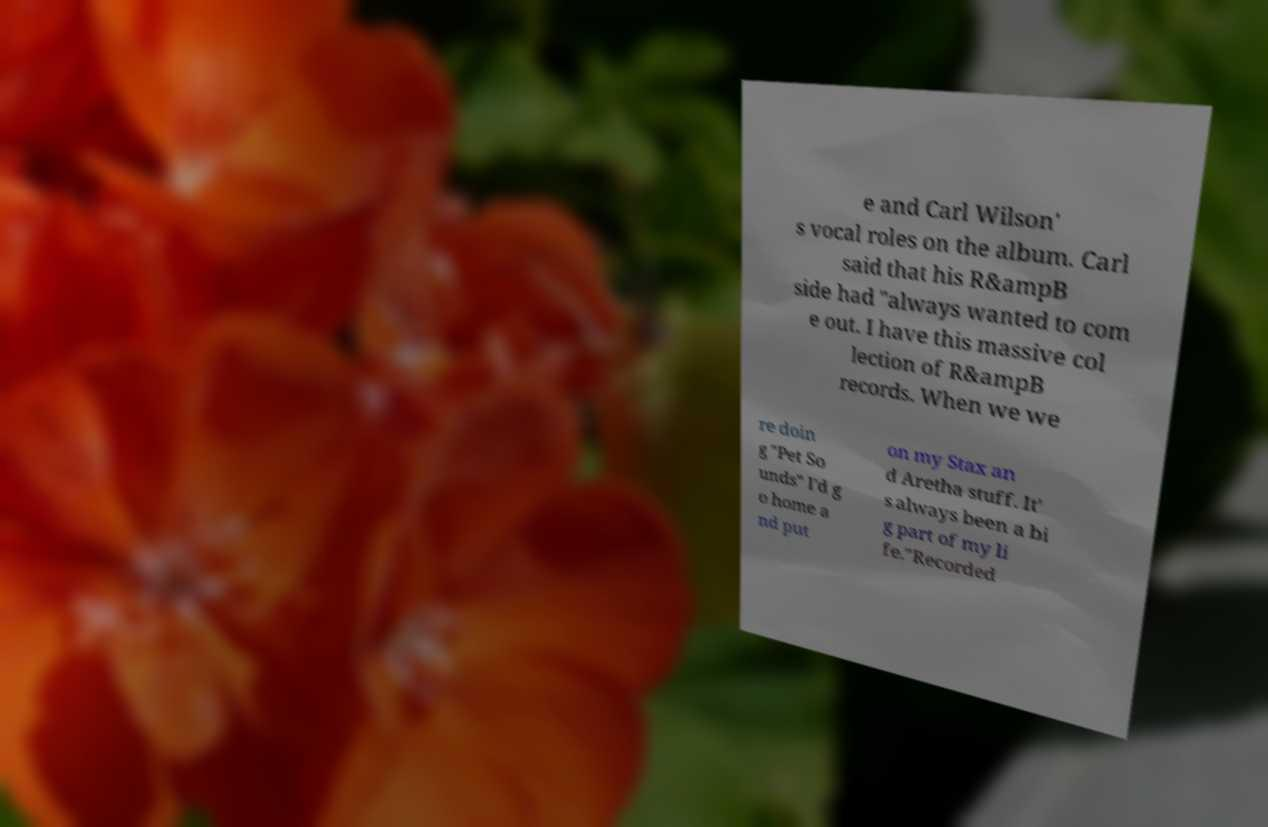What messages or text are displayed in this image? I need them in a readable, typed format. e and Carl Wilson' s vocal roles on the album. Carl said that his R&ampB side had "always wanted to com e out. I have this massive col lection of R&ampB records. When we we re doin g "Pet So unds" I'd g o home a nd put on my Stax an d Aretha stuff. It' s always been a bi g part of my li fe."Recorded 